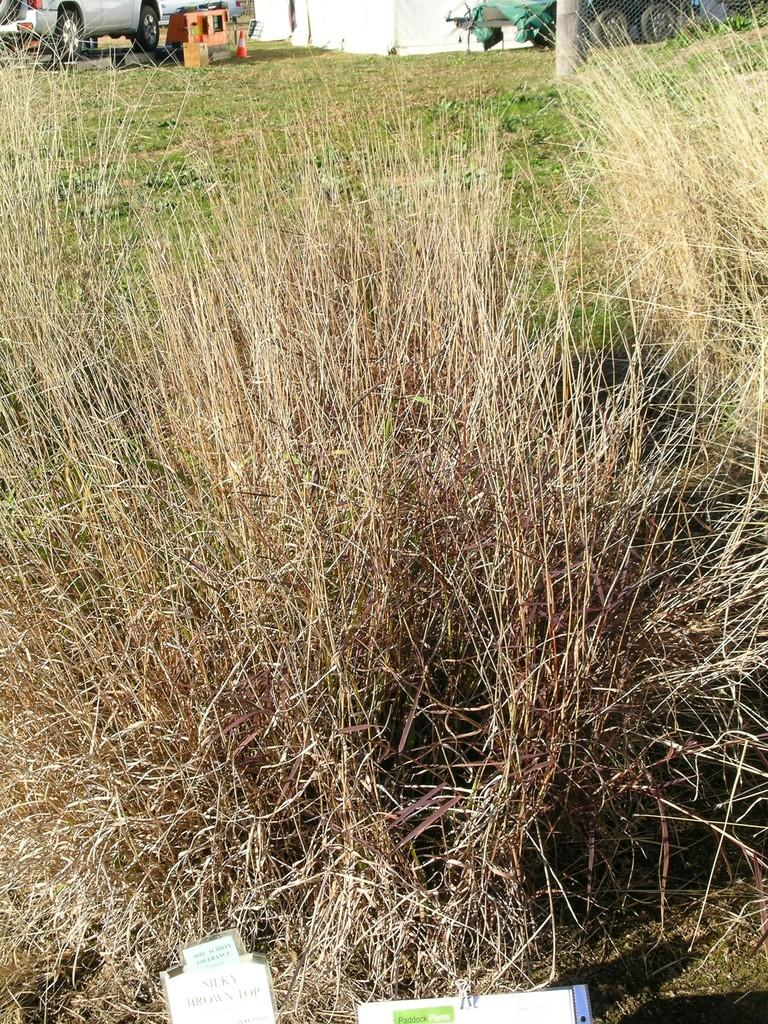What type of vegetation is in the foreground of the image? There is grass in the foreground of the image. What objects might be present at the bottom of the image? There may be papers at the bottom of the image. What type of objects can be seen at the top of the image? There are vehicles visible at the top of the image. Can you describe any man-made structures in the image? There may be a wall in the image. What else might be visible in the image? A pole may be visible in the image. What type of skin can be seen on the clouds in the image? There are no clouds or skin present in the image. How does the quiet environment affect the vehicles in the image? The image does not mention the environment being quiet, and there is no information about the vehicles being affected by any specific conditions. 